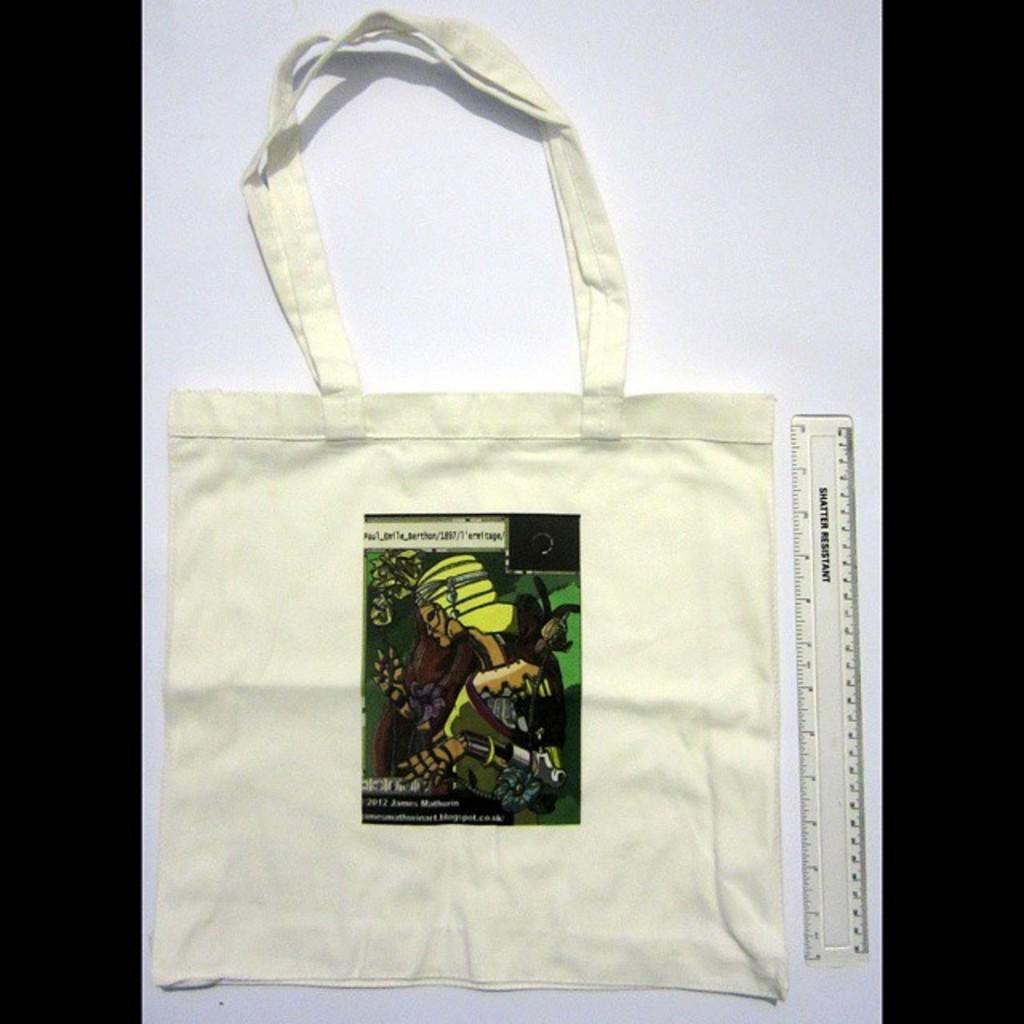What object is present in the image that might be used for carrying items? There is a bag in the image that might be used for carrying items. What additional detail can be observed on the bag? The bag has a label on it. What device is visible in the image that might be used for measuring weight? There is a scale visible in the image that might be used for measuring weight. How many pets are visible in the image? There are no pets present in the image. What type of store is shown in the image? There is no store visible in the image. Is there a minister present in the image? There is no minister present in the image. 